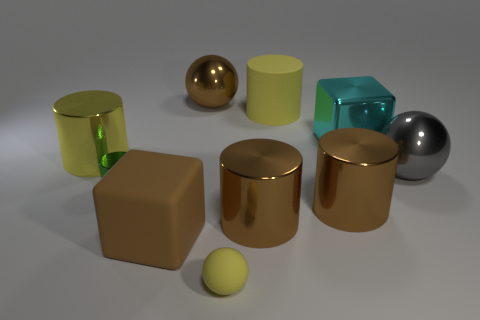How many brown cylinders must be subtracted to get 1 brown cylinders? 1 Subtract all green cylinders. How many cylinders are left? 4 Subtract all green shiny cylinders. How many cylinders are left? 4 Subtract all red cylinders. Subtract all yellow cubes. How many cylinders are left? 5 Subtract all balls. How many objects are left? 7 Subtract all tiny purple rubber cubes. Subtract all brown matte objects. How many objects are left? 9 Add 6 small cylinders. How many small cylinders are left? 7 Add 5 balls. How many balls exist? 8 Subtract 1 brown cubes. How many objects are left? 9 